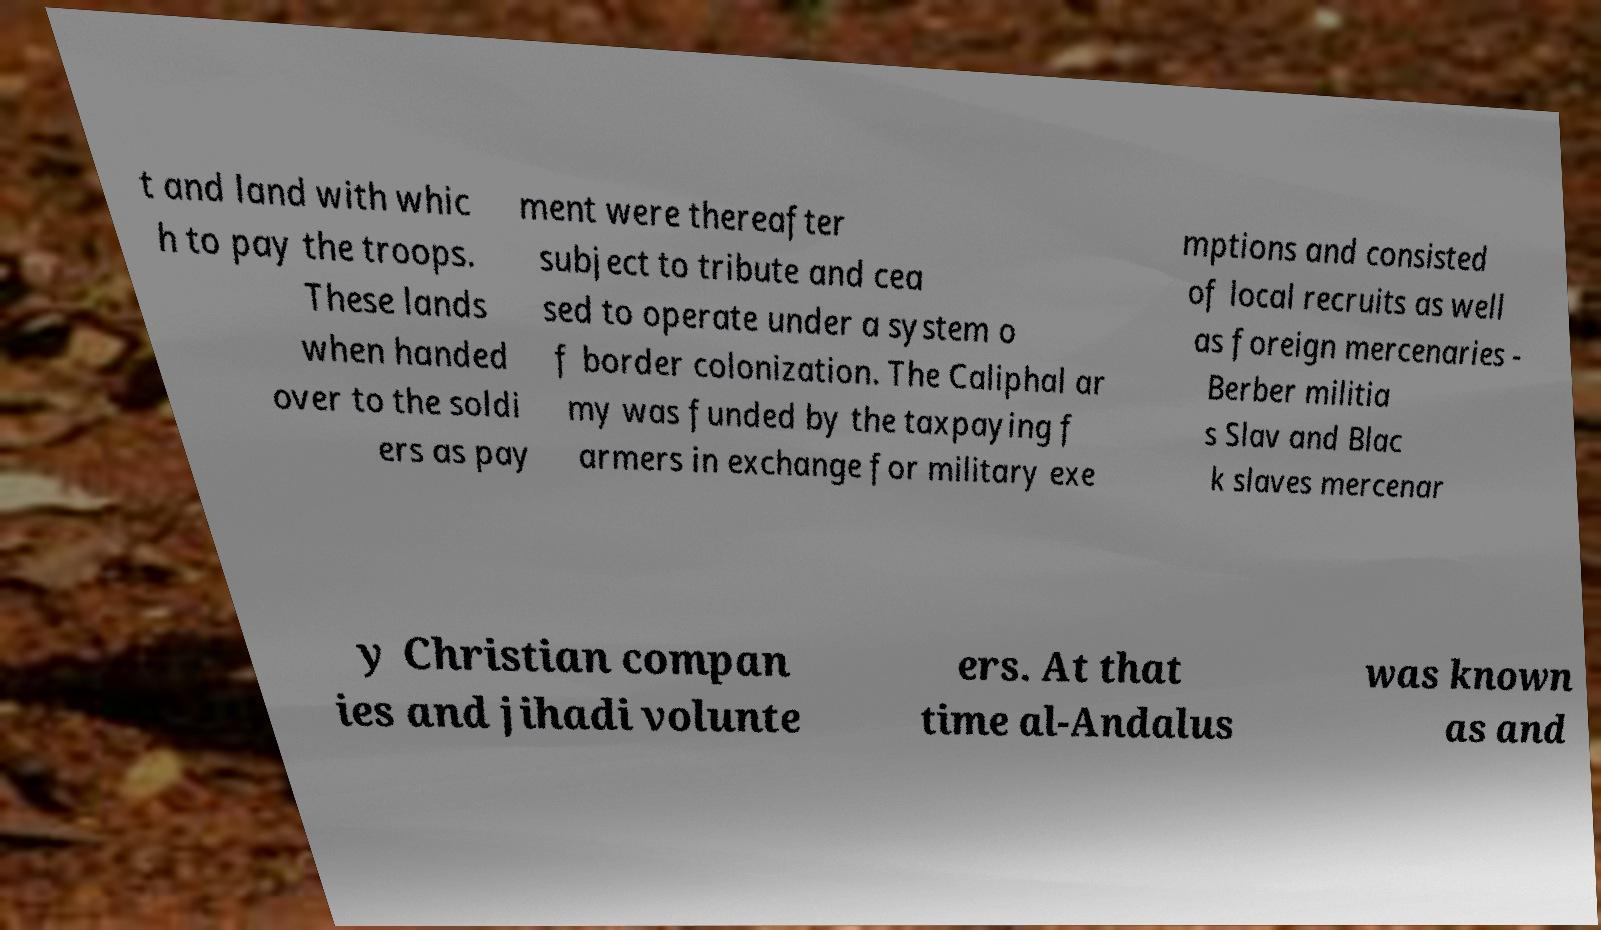Could you extract and type out the text from this image? t and land with whic h to pay the troops. These lands when handed over to the soldi ers as pay ment were thereafter subject to tribute and cea sed to operate under a system o f border colonization. The Caliphal ar my was funded by the taxpaying f armers in exchange for military exe mptions and consisted of local recruits as well as foreign mercenaries - Berber militia s Slav and Blac k slaves mercenar y Christian compan ies and jihadi volunte ers. At that time al-Andalus was known as and 